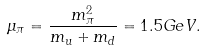Convert formula to latex. <formula><loc_0><loc_0><loc_500><loc_500>\mu _ { \pi } = \frac { m _ { \pi } ^ { 2 } } { m _ { u } + m _ { d } } = 1 . 5 G e V .</formula> 